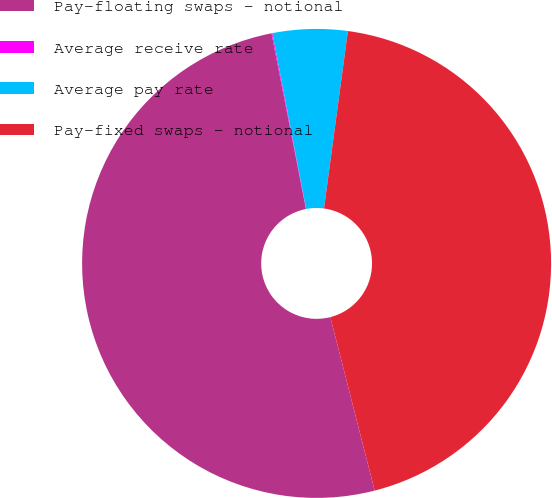Convert chart. <chart><loc_0><loc_0><loc_500><loc_500><pie_chart><fcel>Pay-floating swaps - notional<fcel>Average receive rate<fcel>Average pay rate<fcel>Pay-fixed swaps - notional<nl><fcel>50.9%<fcel>0.06%<fcel>5.15%<fcel>43.88%<nl></chart> 